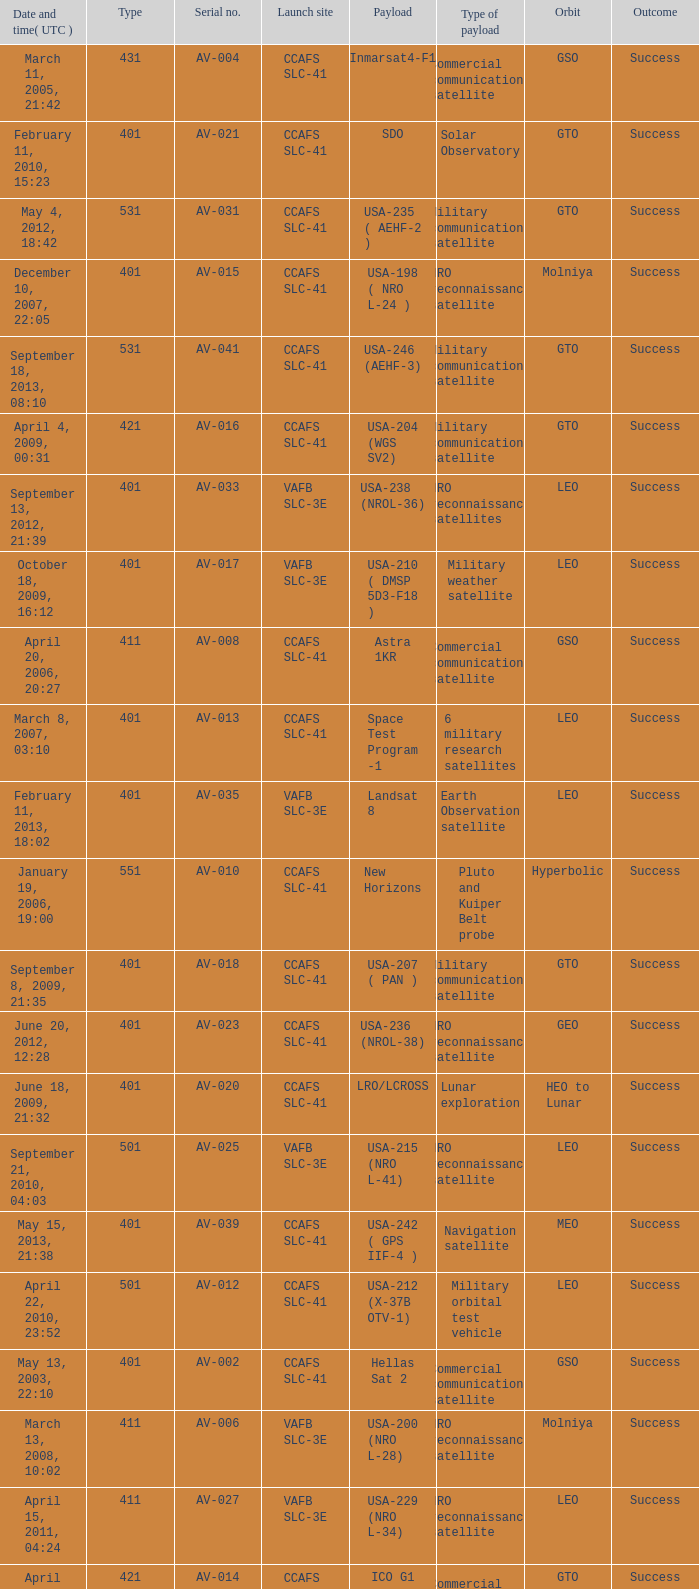For the payload of Van Allen Belts Exploration what's the serial number? AV-032. 